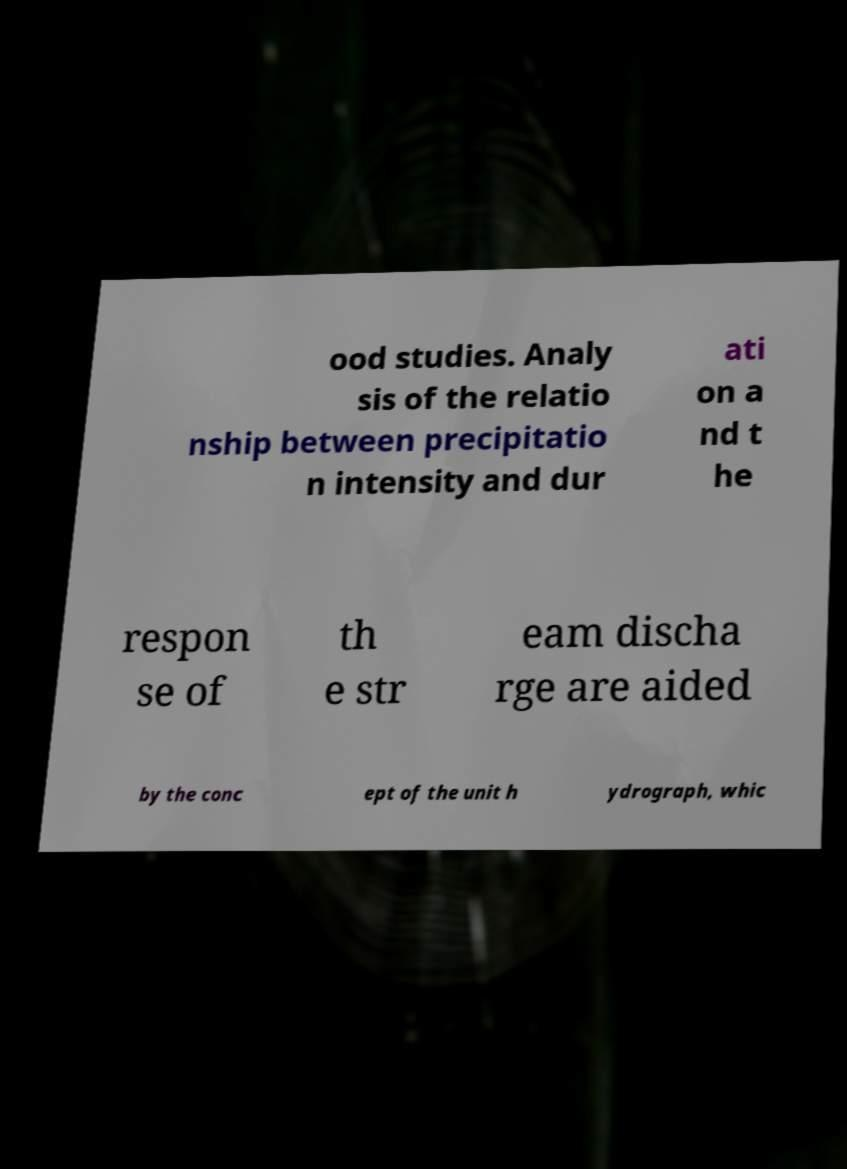Can you read and provide the text displayed in the image?This photo seems to have some interesting text. Can you extract and type it out for me? ood studies. Analy sis of the relatio nship between precipitatio n intensity and dur ati on a nd t he respon se of th e str eam discha rge are aided by the conc ept of the unit h ydrograph, whic 